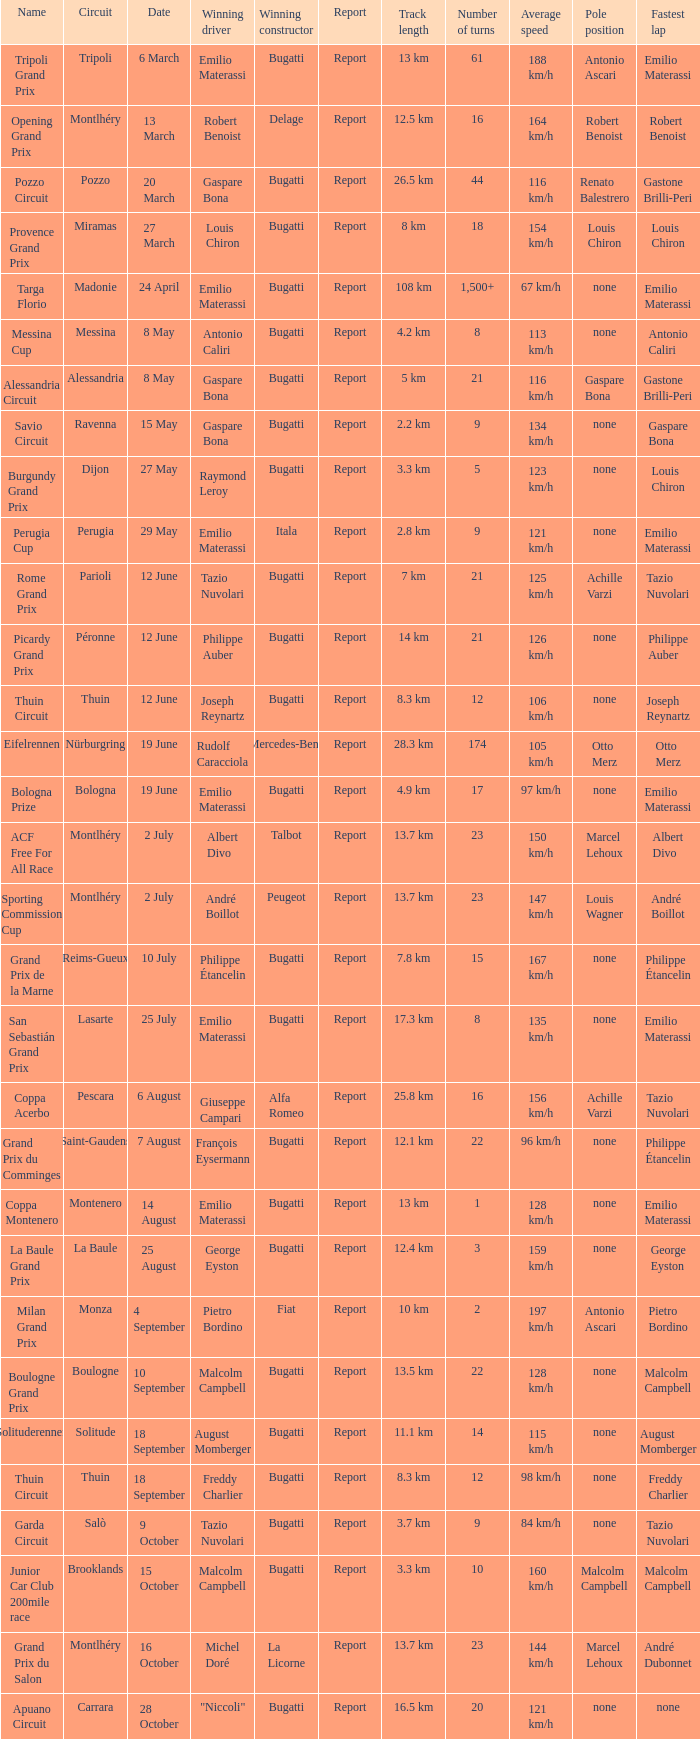Which circuit did françois eysermann win ? Saint-Gaudens. 